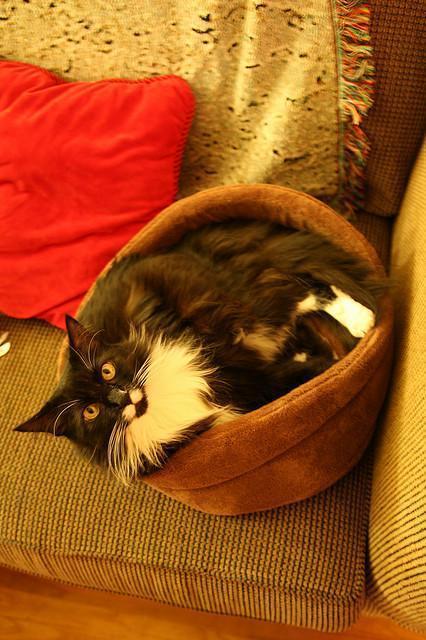How many trains have a number on the front?
Give a very brief answer. 0. 